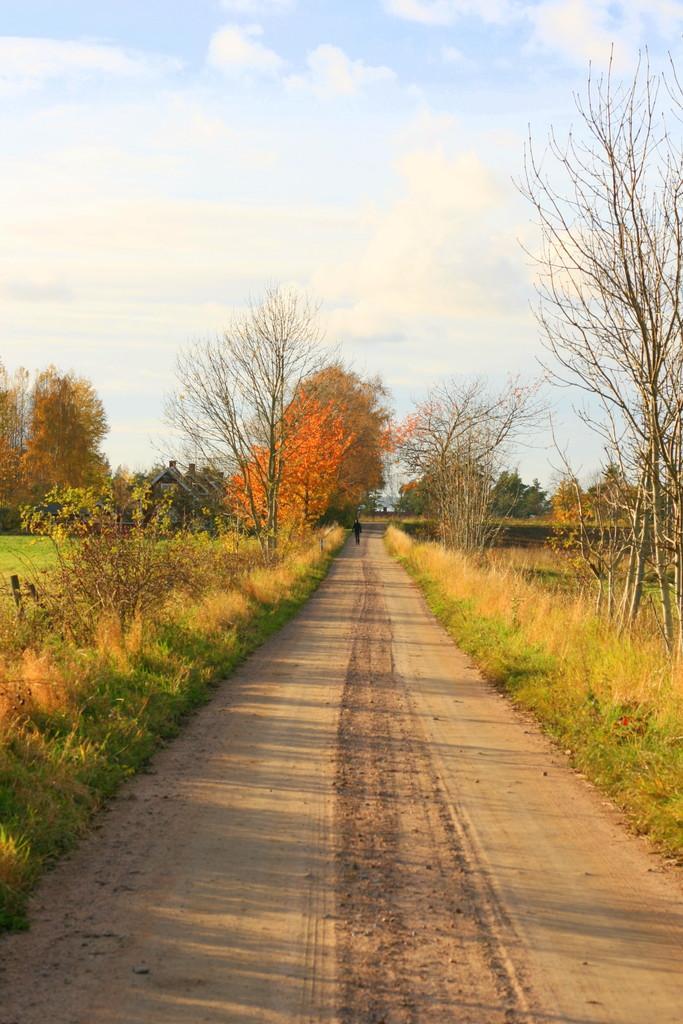Could you give a brief overview of what you see in this image? In this picture we can see path, grass, plants and trees. There is a person standing and we can see houses. In the background of the image we can see the sky. 